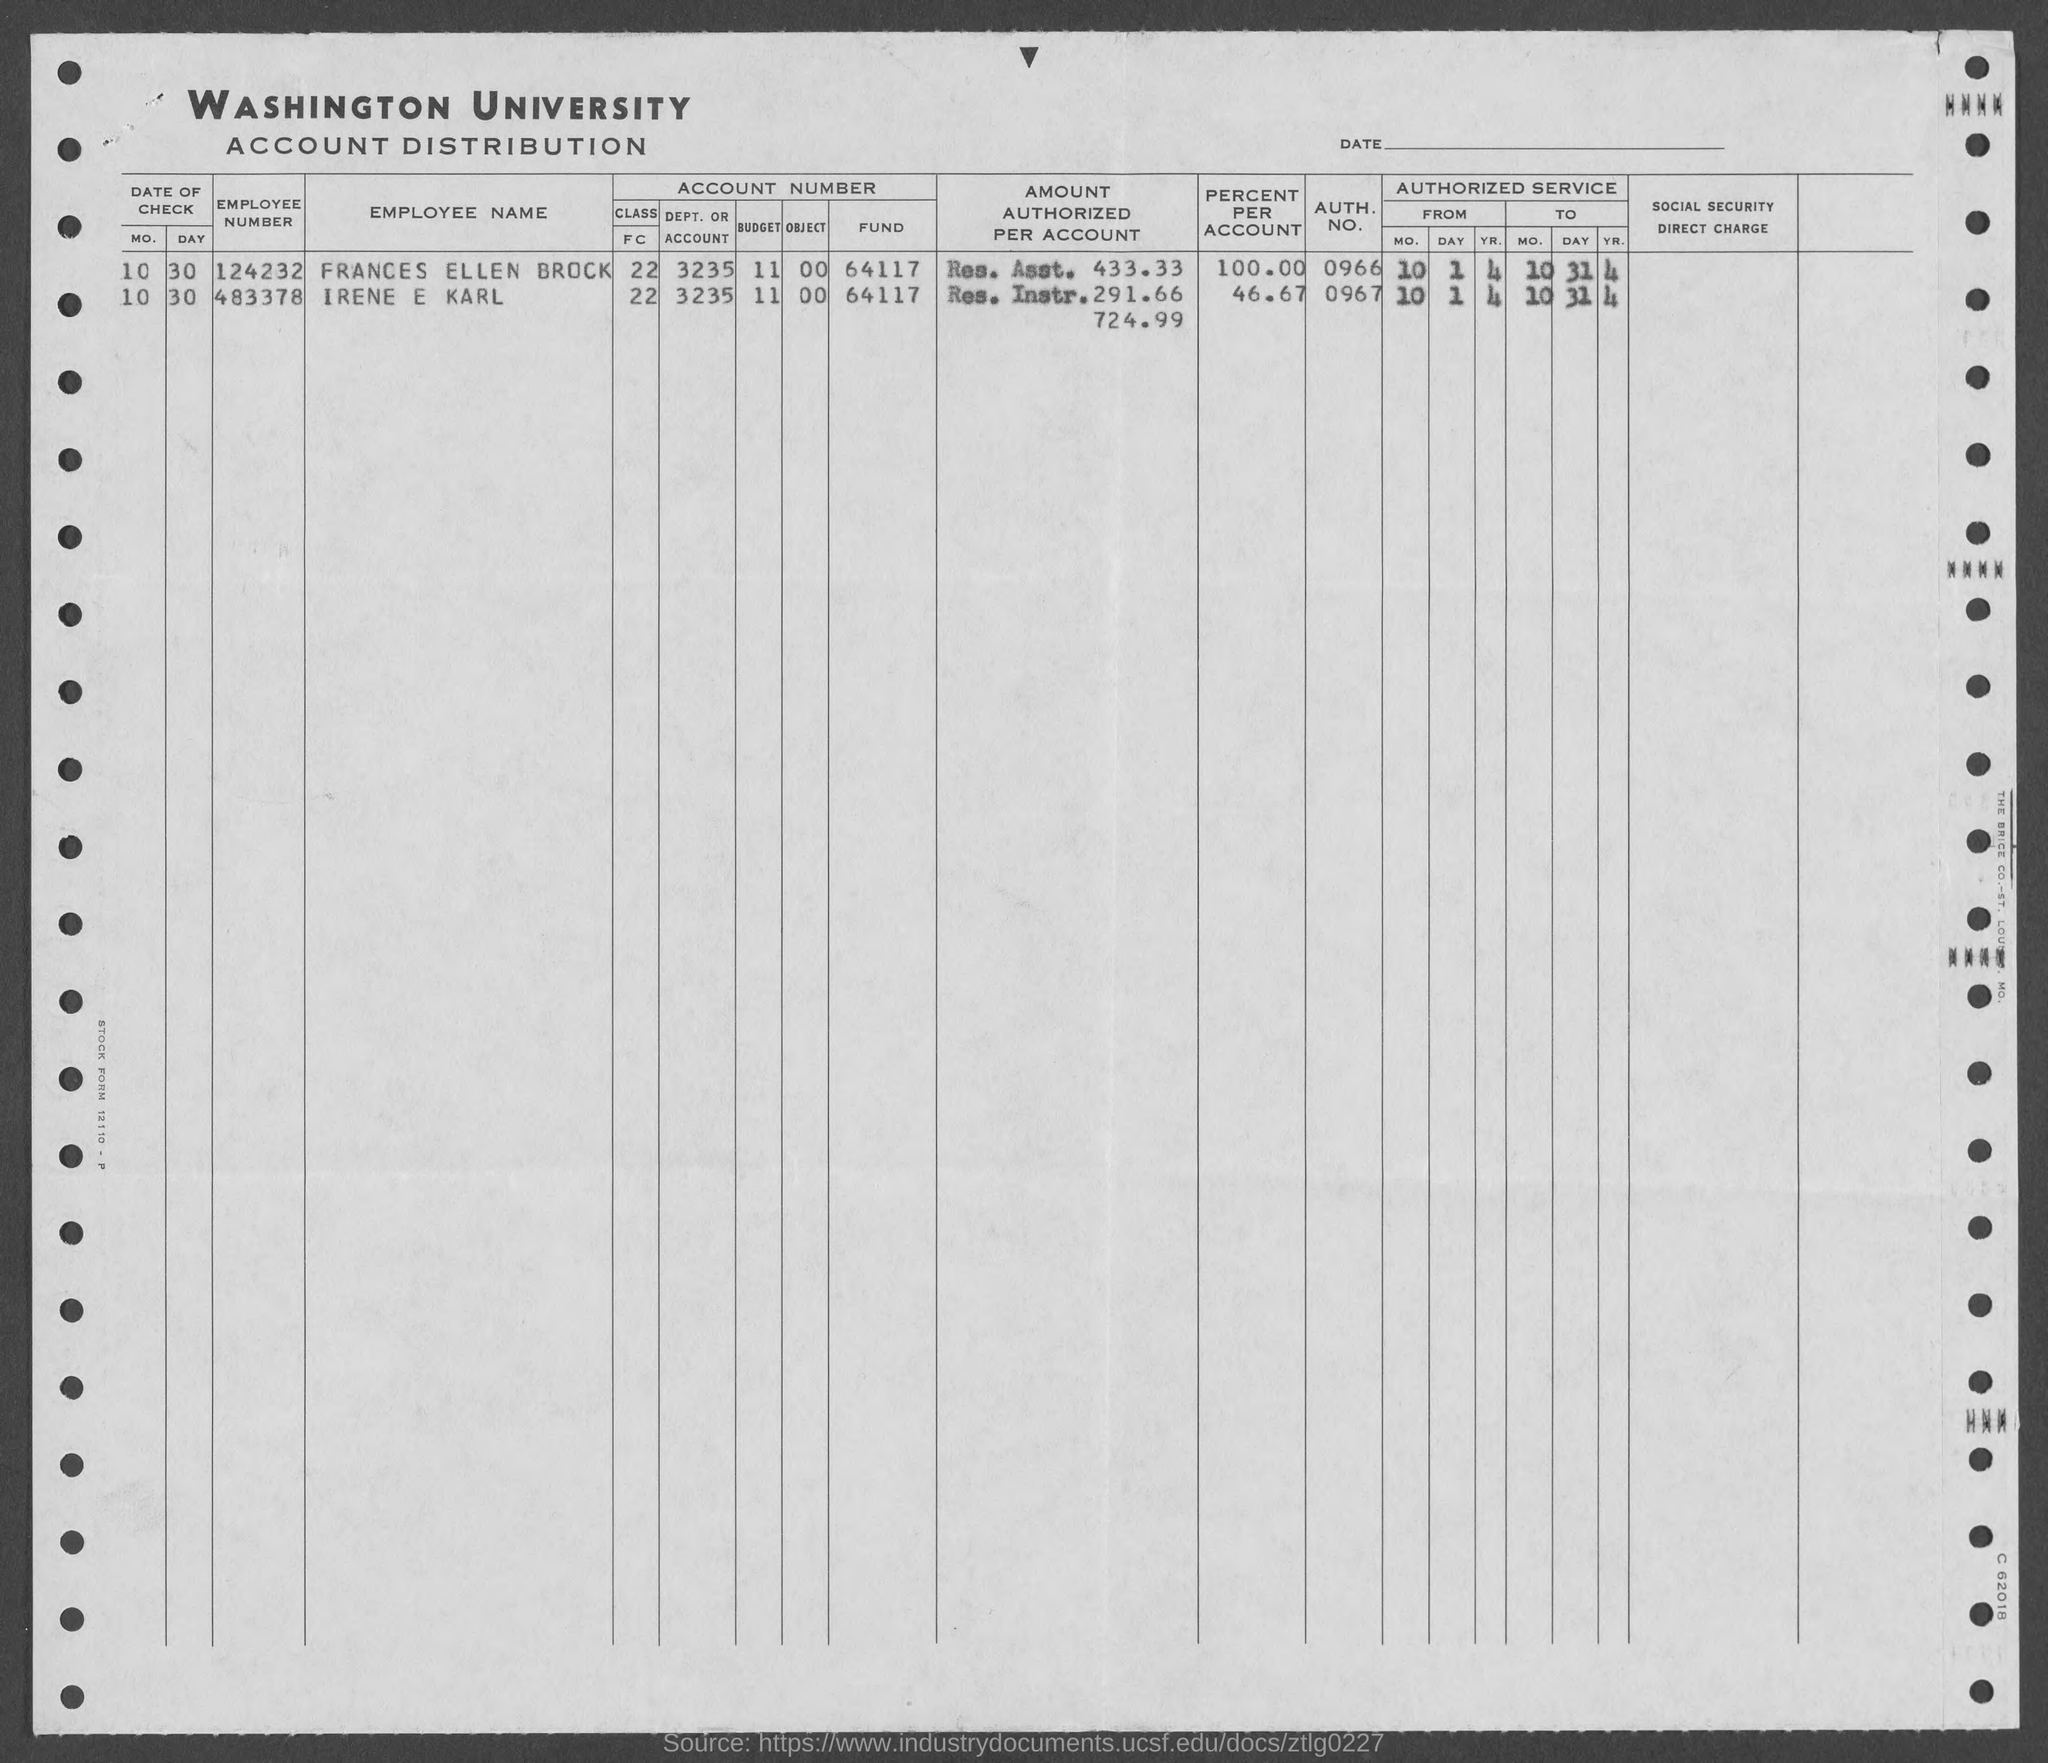Give some essential details in this illustration. The employee number given for Frances Ellen Brock, as mentioned in the provided form, is 124232... The authorization number for Frances Ellen Brock mentioned on the given page is 0966. What is the date of check for Frances Ellen Brock, as of 10/30? The employee number given for Irene E Karl is 483378. The value of the "percent per account" for Irene and Karl, as mentioned in the given form, is 46.67%. 